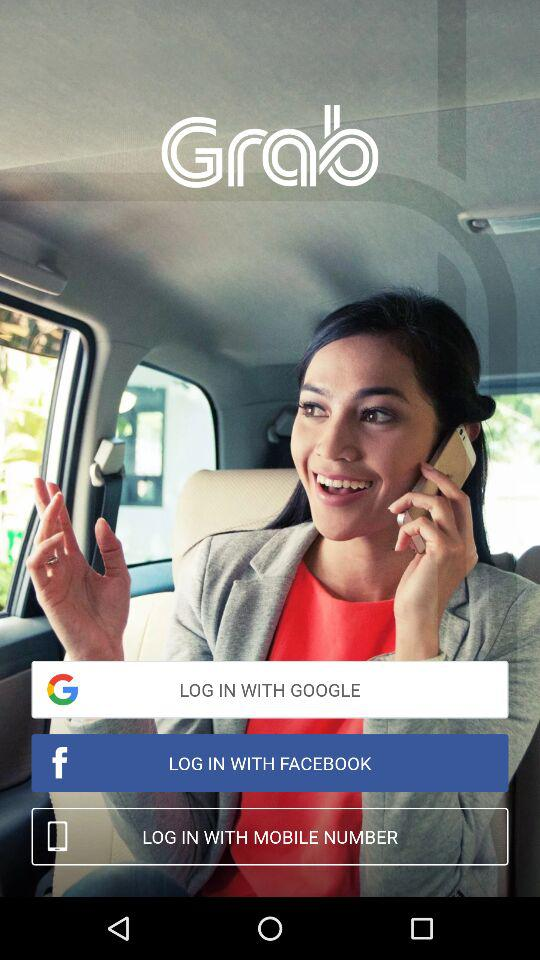What are the login options? The login options are "GOOGLE", "FACEBOOK" and "MOBILE NUMBER". 